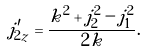Convert formula to latex. <formula><loc_0><loc_0><loc_500><loc_500>j ^ { \prime } _ { 2 z } = \frac { k ^ { 2 } + j _ { 2 } ^ { 2 } - j _ { 1 } ^ { 2 } } { 2 k } .</formula> 